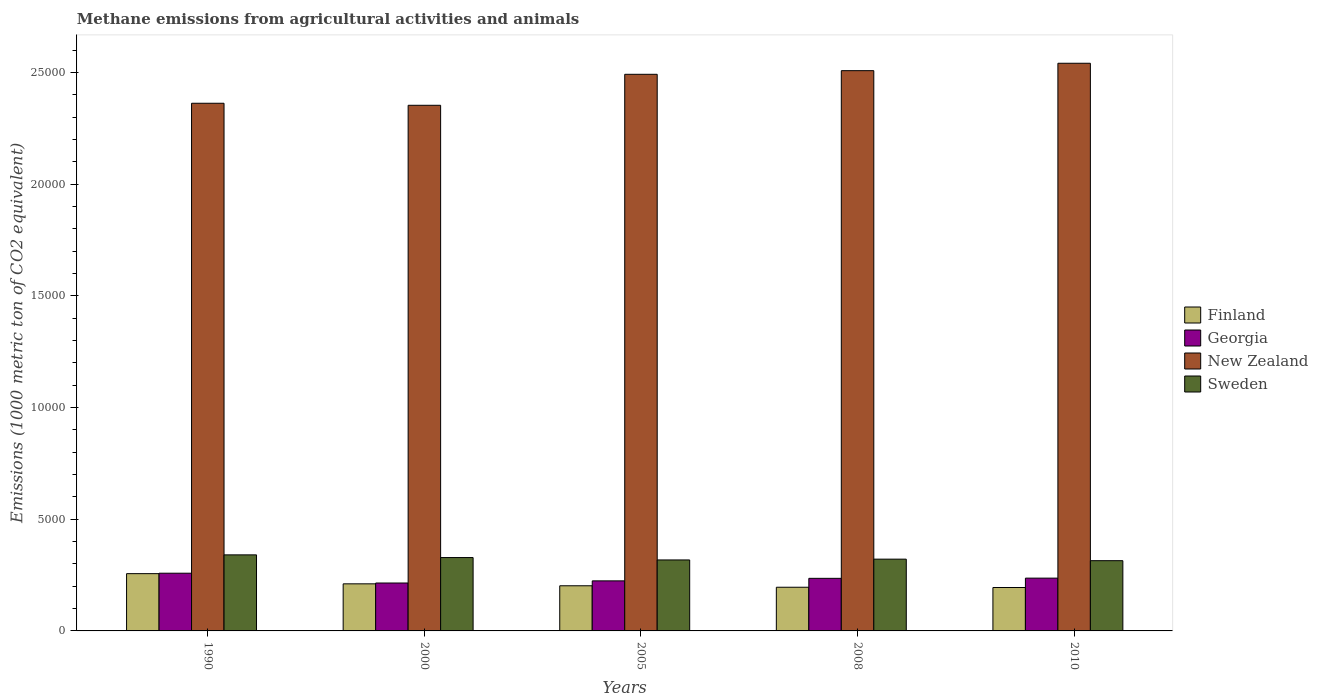How many groups of bars are there?
Offer a very short reply. 5. Are the number of bars per tick equal to the number of legend labels?
Provide a short and direct response. Yes. What is the label of the 1st group of bars from the left?
Provide a short and direct response. 1990. What is the amount of methane emitted in Finland in 2010?
Your answer should be very brief. 1943.6. Across all years, what is the maximum amount of methane emitted in Sweden?
Your response must be concise. 3404.5. Across all years, what is the minimum amount of methane emitted in New Zealand?
Keep it short and to the point. 2.35e+04. What is the total amount of methane emitted in Sweden in the graph?
Give a very brief answer. 1.62e+04. What is the difference between the amount of methane emitted in New Zealand in 2000 and that in 2008?
Keep it short and to the point. -1550.5. What is the difference between the amount of methane emitted in Sweden in 2008 and the amount of methane emitted in New Zealand in 2010?
Offer a terse response. -2.22e+04. What is the average amount of methane emitted in New Zealand per year?
Offer a terse response. 2.45e+04. In the year 2000, what is the difference between the amount of methane emitted in Georgia and amount of methane emitted in Finland?
Your answer should be compact. 37.1. What is the ratio of the amount of methane emitted in New Zealand in 2000 to that in 2008?
Your answer should be compact. 0.94. Is the amount of methane emitted in Georgia in 2005 less than that in 2008?
Offer a very short reply. Yes. What is the difference between the highest and the second highest amount of methane emitted in Georgia?
Ensure brevity in your answer.  220.6. What is the difference between the highest and the lowest amount of methane emitted in Sweden?
Make the answer very short. 259.9. Is it the case that in every year, the sum of the amount of methane emitted in New Zealand and amount of methane emitted in Finland is greater than the sum of amount of methane emitted in Sweden and amount of methane emitted in Georgia?
Your response must be concise. Yes. What does the 3rd bar from the left in 2008 represents?
Give a very brief answer. New Zealand. Is it the case that in every year, the sum of the amount of methane emitted in Sweden and amount of methane emitted in New Zealand is greater than the amount of methane emitted in Georgia?
Provide a short and direct response. Yes. How many years are there in the graph?
Your response must be concise. 5. What is the difference between two consecutive major ticks on the Y-axis?
Your answer should be very brief. 5000. Does the graph contain any zero values?
Make the answer very short. No. How many legend labels are there?
Provide a short and direct response. 4. What is the title of the graph?
Offer a very short reply. Methane emissions from agricultural activities and animals. What is the label or title of the Y-axis?
Give a very brief answer. Emissions (1000 metric ton of CO2 equivalent). What is the Emissions (1000 metric ton of CO2 equivalent) in Finland in 1990?
Offer a terse response. 2564. What is the Emissions (1000 metric ton of CO2 equivalent) in Georgia in 1990?
Provide a short and direct response. 2583.7. What is the Emissions (1000 metric ton of CO2 equivalent) of New Zealand in 1990?
Provide a succinct answer. 2.36e+04. What is the Emissions (1000 metric ton of CO2 equivalent) of Sweden in 1990?
Provide a succinct answer. 3404.5. What is the Emissions (1000 metric ton of CO2 equivalent) of Finland in 2000?
Your answer should be compact. 2107.9. What is the Emissions (1000 metric ton of CO2 equivalent) in Georgia in 2000?
Your answer should be compact. 2145. What is the Emissions (1000 metric ton of CO2 equivalent) of New Zealand in 2000?
Keep it short and to the point. 2.35e+04. What is the Emissions (1000 metric ton of CO2 equivalent) of Sweden in 2000?
Your response must be concise. 3284.7. What is the Emissions (1000 metric ton of CO2 equivalent) in Finland in 2005?
Your response must be concise. 2020.8. What is the Emissions (1000 metric ton of CO2 equivalent) of Georgia in 2005?
Your response must be concise. 2240.7. What is the Emissions (1000 metric ton of CO2 equivalent) of New Zealand in 2005?
Keep it short and to the point. 2.49e+04. What is the Emissions (1000 metric ton of CO2 equivalent) in Sweden in 2005?
Your answer should be compact. 3177.6. What is the Emissions (1000 metric ton of CO2 equivalent) in Finland in 2008?
Make the answer very short. 1955.7. What is the Emissions (1000 metric ton of CO2 equivalent) of Georgia in 2008?
Your answer should be compact. 2354. What is the Emissions (1000 metric ton of CO2 equivalent) of New Zealand in 2008?
Make the answer very short. 2.51e+04. What is the Emissions (1000 metric ton of CO2 equivalent) of Sweden in 2008?
Offer a terse response. 3213.3. What is the Emissions (1000 metric ton of CO2 equivalent) of Finland in 2010?
Provide a short and direct response. 1943.6. What is the Emissions (1000 metric ton of CO2 equivalent) in Georgia in 2010?
Provide a short and direct response. 2363.1. What is the Emissions (1000 metric ton of CO2 equivalent) in New Zealand in 2010?
Provide a short and direct response. 2.54e+04. What is the Emissions (1000 metric ton of CO2 equivalent) of Sweden in 2010?
Your answer should be very brief. 3144.6. Across all years, what is the maximum Emissions (1000 metric ton of CO2 equivalent) in Finland?
Your answer should be very brief. 2564. Across all years, what is the maximum Emissions (1000 metric ton of CO2 equivalent) of Georgia?
Offer a very short reply. 2583.7. Across all years, what is the maximum Emissions (1000 metric ton of CO2 equivalent) of New Zealand?
Keep it short and to the point. 2.54e+04. Across all years, what is the maximum Emissions (1000 metric ton of CO2 equivalent) of Sweden?
Offer a terse response. 3404.5. Across all years, what is the minimum Emissions (1000 metric ton of CO2 equivalent) of Finland?
Provide a short and direct response. 1943.6. Across all years, what is the minimum Emissions (1000 metric ton of CO2 equivalent) of Georgia?
Your answer should be very brief. 2145. Across all years, what is the minimum Emissions (1000 metric ton of CO2 equivalent) of New Zealand?
Keep it short and to the point. 2.35e+04. Across all years, what is the minimum Emissions (1000 metric ton of CO2 equivalent) in Sweden?
Offer a very short reply. 3144.6. What is the total Emissions (1000 metric ton of CO2 equivalent) of Finland in the graph?
Keep it short and to the point. 1.06e+04. What is the total Emissions (1000 metric ton of CO2 equivalent) of Georgia in the graph?
Offer a terse response. 1.17e+04. What is the total Emissions (1000 metric ton of CO2 equivalent) in New Zealand in the graph?
Your response must be concise. 1.23e+05. What is the total Emissions (1000 metric ton of CO2 equivalent) of Sweden in the graph?
Make the answer very short. 1.62e+04. What is the difference between the Emissions (1000 metric ton of CO2 equivalent) in Finland in 1990 and that in 2000?
Provide a succinct answer. 456.1. What is the difference between the Emissions (1000 metric ton of CO2 equivalent) of Georgia in 1990 and that in 2000?
Your answer should be very brief. 438.7. What is the difference between the Emissions (1000 metric ton of CO2 equivalent) of New Zealand in 1990 and that in 2000?
Make the answer very short. 90.9. What is the difference between the Emissions (1000 metric ton of CO2 equivalent) of Sweden in 1990 and that in 2000?
Offer a terse response. 119.8. What is the difference between the Emissions (1000 metric ton of CO2 equivalent) of Finland in 1990 and that in 2005?
Provide a short and direct response. 543.2. What is the difference between the Emissions (1000 metric ton of CO2 equivalent) in Georgia in 1990 and that in 2005?
Ensure brevity in your answer.  343. What is the difference between the Emissions (1000 metric ton of CO2 equivalent) in New Zealand in 1990 and that in 2005?
Make the answer very short. -1296. What is the difference between the Emissions (1000 metric ton of CO2 equivalent) in Sweden in 1990 and that in 2005?
Offer a terse response. 226.9. What is the difference between the Emissions (1000 metric ton of CO2 equivalent) in Finland in 1990 and that in 2008?
Your response must be concise. 608.3. What is the difference between the Emissions (1000 metric ton of CO2 equivalent) of Georgia in 1990 and that in 2008?
Your answer should be compact. 229.7. What is the difference between the Emissions (1000 metric ton of CO2 equivalent) of New Zealand in 1990 and that in 2008?
Ensure brevity in your answer.  -1459.6. What is the difference between the Emissions (1000 metric ton of CO2 equivalent) of Sweden in 1990 and that in 2008?
Offer a terse response. 191.2. What is the difference between the Emissions (1000 metric ton of CO2 equivalent) of Finland in 1990 and that in 2010?
Give a very brief answer. 620.4. What is the difference between the Emissions (1000 metric ton of CO2 equivalent) in Georgia in 1990 and that in 2010?
Make the answer very short. 220.6. What is the difference between the Emissions (1000 metric ton of CO2 equivalent) of New Zealand in 1990 and that in 2010?
Your response must be concise. -1790.8. What is the difference between the Emissions (1000 metric ton of CO2 equivalent) in Sweden in 1990 and that in 2010?
Give a very brief answer. 259.9. What is the difference between the Emissions (1000 metric ton of CO2 equivalent) of Finland in 2000 and that in 2005?
Your answer should be compact. 87.1. What is the difference between the Emissions (1000 metric ton of CO2 equivalent) in Georgia in 2000 and that in 2005?
Ensure brevity in your answer.  -95.7. What is the difference between the Emissions (1000 metric ton of CO2 equivalent) of New Zealand in 2000 and that in 2005?
Provide a succinct answer. -1386.9. What is the difference between the Emissions (1000 metric ton of CO2 equivalent) of Sweden in 2000 and that in 2005?
Provide a short and direct response. 107.1. What is the difference between the Emissions (1000 metric ton of CO2 equivalent) of Finland in 2000 and that in 2008?
Offer a terse response. 152.2. What is the difference between the Emissions (1000 metric ton of CO2 equivalent) of Georgia in 2000 and that in 2008?
Give a very brief answer. -209. What is the difference between the Emissions (1000 metric ton of CO2 equivalent) of New Zealand in 2000 and that in 2008?
Make the answer very short. -1550.5. What is the difference between the Emissions (1000 metric ton of CO2 equivalent) of Sweden in 2000 and that in 2008?
Your answer should be very brief. 71.4. What is the difference between the Emissions (1000 metric ton of CO2 equivalent) of Finland in 2000 and that in 2010?
Give a very brief answer. 164.3. What is the difference between the Emissions (1000 metric ton of CO2 equivalent) in Georgia in 2000 and that in 2010?
Give a very brief answer. -218.1. What is the difference between the Emissions (1000 metric ton of CO2 equivalent) of New Zealand in 2000 and that in 2010?
Your response must be concise. -1881.7. What is the difference between the Emissions (1000 metric ton of CO2 equivalent) of Sweden in 2000 and that in 2010?
Your response must be concise. 140.1. What is the difference between the Emissions (1000 metric ton of CO2 equivalent) in Finland in 2005 and that in 2008?
Give a very brief answer. 65.1. What is the difference between the Emissions (1000 metric ton of CO2 equivalent) in Georgia in 2005 and that in 2008?
Provide a succinct answer. -113.3. What is the difference between the Emissions (1000 metric ton of CO2 equivalent) of New Zealand in 2005 and that in 2008?
Provide a short and direct response. -163.6. What is the difference between the Emissions (1000 metric ton of CO2 equivalent) of Sweden in 2005 and that in 2008?
Ensure brevity in your answer.  -35.7. What is the difference between the Emissions (1000 metric ton of CO2 equivalent) in Finland in 2005 and that in 2010?
Offer a terse response. 77.2. What is the difference between the Emissions (1000 metric ton of CO2 equivalent) in Georgia in 2005 and that in 2010?
Make the answer very short. -122.4. What is the difference between the Emissions (1000 metric ton of CO2 equivalent) in New Zealand in 2005 and that in 2010?
Your answer should be compact. -494.8. What is the difference between the Emissions (1000 metric ton of CO2 equivalent) in Sweden in 2005 and that in 2010?
Ensure brevity in your answer.  33. What is the difference between the Emissions (1000 metric ton of CO2 equivalent) in New Zealand in 2008 and that in 2010?
Ensure brevity in your answer.  -331.2. What is the difference between the Emissions (1000 metric ton of CO2 equivalent) in Sweden in 2008 and that in 2010?
Provide a short and direct response. 68.7. What is the difference between the Emissions (1000 metric ton of CO2 equivalent) in Finland in 1990 and the Emissions (1000 metric ton of CO2 equivalent) in Georgia in 2000?
Your answer should be very brief. 419. What is the difference between the Emissions (1000 metric ton of CO2 equivalent) in Finland in 1990 and the Emissions (1000 metric ton of CO2 equivalent) in New Zealand in 2000?
Provide a short and direct response. -2.10e+04. What is the difference between the Emissions (1000 metric ton of CO2 equivalent) in Finland in 1990 and the Emissions (1000 metric ton of CO2 equivalent) in Sweden in 2000?
Offer a terse response. -720.7. What is the difference between the Emissions (1000 metric ton of CO2 equivalent) in Georgia in 1990 and the Emissions (1000 metric ton of CO2 equivalent) in New Zealand in 2000?
Provide a succinct answer. -2.09e+04. What is the difference between the Emissions (1000 metric ton of CO2 equivalent) in Georgia in 1990 and the Emissions (1000 metric ton of CO2 equivalent) in Sweden in 2000?
Offer a very short reply. -701. What is the difference between the Emissions (1000 metric ton of CO2 equivalent) in New Zealand in 1990 and the Emissions (1000 metric ton of CO2 equivalent) in Sweden in 2000?
Offer a terse response. 2.03e+04. What is the difference between the Emissions (1000 metric ton of CO2 equivalent) of Finland in 1990 and the Emissions (1000 metric ton of CO2 equivalent) of Georgia in 2005?
Keep it short and to the point. 323.3. What is the difference between the Emissions (1000 metric ton of CO2 equivalent) in Finland in 1990 and the Emissions (1000 metric ton of CO2 equivalent) in New Zealand in 2005?
Your answer should be very brief. -2.24e+04. What is the difference between the Emissions (1000 metric ton of CO2 equivalent) of Finland in 1990 and the Emissions (1000 metric ton of CO2 equivalent) of Sweden in 2005?
Make the answer very short. -613.6. What is the difference between the Emissions (1000 metric ton of CO2 equivalent) in Georgia in 1990 and the Emissions (1000 metric ton of CO2 equivalent) in New Zealand in 2005?
Keep it short and to the point. -2.23e+04. What is the difference between the Emissions (1000 metric ton of CO2 equivalent) in Georgia in 1990 and the Emissions (1000 metric ton of CO2 equivalent) in Sweden in 2005?
Offer a terse response. -593.9. What is the difference between the Emissions (1000 metric ton of CO2 equivalent) in New Zealand in 1990 and the Emissions (1000 metric ton of CO2 equivalent) in Sweden in 2005?
Your answer should be compact. 2.04e+04. What is the difference between the Emissions (1000 metric ton of CO2 equivalent) in Finland in 1990 and the Emissions (1000 metric ton of CO2 equivalent) in Georgia in 2008?
Make the answer very short. 210. What is the difference between the Emissions (1000 metric ton of CO2 equivalent) in Finland in 1990 and the Emissions (1000 metric ton of CO2 equivalent) in New Zealand in 2008?
Your response must be concise. -2.25e+04. What is the difference between the Emissions (1000 metric ton of CO2 equivalent) of Finland in 1990 and the Emissions (1000 metric ton of CO2 equivalent) of Sweden in 2008?
Offer a terse response. -649.3. What is the difference between the Emissions (1000 metric ton of CO2 equivalent) of Georgia in 1990 and the Emissions (1000 metric ton of CO2 equivalent) of New Zealand in 2008?
Offer a very short reply. -2.25e+04. What is the difference between the Emissions (1000 metric ton of CO2 equivalent) in Georgia in 1990 and the Emissions (1000 metric ton of CO2 equivalent) in Sweden in 2008?
Give a very brief answer. -629.6. What is the difference between the Emissions (1000 metric ton of CO2 equivalent) in New Zealand in 1990 and the Emissions (1000 metric ton of CO2 equivalent) in Sweden in 2008?
Offer a very short reply. 2.04e+04. What is the difference between the Emissions (1000 metric ton of CO2 equivalent) of Finland in 1990 and the Emissions (1000 metric ton of CO2 equivalent) of Georgia in 2010?
Give a very brief answer. 200.9. What is the difference between the Emissions (1000 metric ton of CO2 equivalent) in Finland in 1990 and the Emissions (1000 metric ton of CO2 equivalent) in New Zealand in 2010?
Your answer should be compact. -2.28e+04. What is the difference between the Emissions (1000 metric ton of CO2 equivalent) of Finland in 1990 and the Emissions (1000 metric ton of CO2 equivalent) of Sweden in 2010?
Offer a very short reply. -580.6. What is the difference between the Emissions (1000 metric ton of CO2 equivalent) in Georgia in 1990 and the Emissions (1000 metric ton of CO2 equivalent) in New Zealand in 2010?
Make the answer very short. -2.28e+04. What is the difference between the Emissions (1000 metric ton of CO2 equivalent) of Georgia in 1990 and the Emissions (1000 metric ton of CO2 equivalent) of Sweden in 2010?
Offer a very short reply. -560.9. What is the difference between the Emissions (1000 metric ton of CO2 equivalent) in New Zealand in 1990 and the Emissions (1000 metric ton of CO2 equivalent) in Sweden in 2010?
Make the answer very short. 2.05e+04. What is the difference between the Emissions (1000 metric ton of CO2 equivalent) in Finland in 2000 and the Emissions (1000 metric ton of CO2 equivalent) in Georgia in 2005?
Keep it short and to the point. -132.8. What is the difference between the Emissions (1000 metric ton of CO2 equivalent) in Finland in 2000 and the Emissions (1000 metric ton of CO2 equivalent) in New Zealand in 2005?
Ensure brevity in your answer.  -2.28e+04. What is the difference between the Emissions (1000 metric ton of CO2 equivalent) in Finland in 2000 and the Emissions (1000 metric ton of CO2 equivalent) in Sweden in 2005?
Your answer should be very brief. -1069.7. What is the difference between the Emissions (1000 metric ton of CO2 equivalent) in Georgia in 2000 and the Emissions (1000 metric ton of CO2 equivalent) in New Zealand in 2005?
Provide a succinct answer. -2.28e+04. What is the difference between the Emissions (1000 metric ton of CO2 equivalent) in Georgia in 2000 and the Emissions (1000 metric ton of CO2 equivalent) in Sweden in 2005?
Ensure brevity in your answer.  -1032.6. What is the difference between the Emissions (1000 metric ton of CO2 equivalent) of New Zealand in 2000 and the Emissions (1000 metric ton of CO2 equivalent) of Sweden in 2005?
Make the answer very short. 2.04e+04. What is the difference between the Emissions (1000 metric ton of CO2 equivalent) of Finland in 2000 and the Emissions (1000 metric ton of CO2 equivalent) of Georgia in 2008?
Ensure brevity in your answer.  -246.1. What is the difference between the Emissions (1000 metric ton of CO2 equivalent) in Finland in 2000 and the Emissions (1000 metric ton of CO2 equivalent) in New Zealand in 2008?
Ensure brevity in your answer.  -2.30e+04. What is the difference between the Emissions (1000 metric ton of CO2 equivalent) in Finland in 2000 and the Emissions (1000 metric ton of CO2 equivalent) in Sweden in 2008?
Offer a very short reply. -1105.4. What is the difference between the Emissions (1000 metric ton of CO2 equivalent) in Georgia in 2000 and the Emissions (1000 metric ton of CO2 equivalent) in New Zealand in 2008?
Provide a succinct answer. -2.29e+04. What is the difference between the Emissions (1000 metric ton of CO2 equivalent) in Georgia in 2000 and the Emissions (1000 metric ton of CO2 equivalent) in Sweden in 2008?
Offer a very short reply. -1068.3. What is the difference between the Emissions (1000 metric ton of CO2 equivalent) in New Zealand in 2000 and the Emissions (1000 metric ton of CO2 equivalent) in Sweden in 2008?
Provide a succinct answer. 2.03e+04. What is the difference between the Emissions (1000 metric ton of CO2 equivalent) of Finland in 2000 and the Emissions (1000 metric ton of CO2 equivalent) of Georgia in 2010?
Offer a terse response. -255.2. What is the difference between the Emissions (1000 metric ton of CO2 equivalent) of Finland in 2000 and the Emissions (1000 metric ton of CO2 equivalent) of New Zealand in 2010?
Your response must be concise. -2.33e+04. What is the difference between the Emissions (1000 metric ton of CO2 equivalent) in Finland in 2000 and the Emissions (1000 metric ton of CO2 equivalent) in Sweden in 2010?
Your response must be concise. -1036.7. What is the difference between the Emissions (1000 metric ton of CO2 equivalent) of Georgia in 2000 and the Emissions (1000 metric ton of CO2 equivalent) of New Zealand in 2010?
Offer a very short reply. -2.33e+04. What is the difference between the Emissions (1000 metric ton of CO2 equivalent) in Georgia in 2000 and the Emissions (1000 metric ton of CO2 equivalent) in Sweden in 2010?
Your answer should be very brief. -999.6. What is the difference between the Emissions (1000 metric ton of CO2 equivalent) of New Zealand in 2000 and the Emissions (1000 metric ton of CO2 equivalent) of Sweden in 2010?
Make the answer very short. 2.04e+04. What is the difference between the Emissions (1000 metric ton of CO2 equivalent) of Finland in 2005 and the Emissions (1000 metric ton of CO2 equivalent) of Georgia in 2008?
Provide a short and direct response. -333.2. What is the difference between the Emissions (1000 metric ton of CO2 equivalent) of Finland in 2005 and the Emissions (1000 metric ton of CO2 equivalent) of New Zealand in 2008?
Ensure brevity in your answer.  -2.31e+04. What is the difference between the Emissions (1000 metric ton of CO2 equivalent) of Finland in 2005 and the Emissions (1000 metric ton of CO2 equivalent) of Sweden in 2008?
Offer a very short reply. -1192.5. What is the difference between the Emissions (1000 metric ton of CO2 equivalent) of Georgia in 2005 and the Emissions (1000 metric ton of CO2 equivalent) of New Zealand in 2008?
Ensure brevity in your answer.  -2.28e+04. What is the difference between the Emissions (1000 metric ton of CO2 equivalent) in Georgia in 2005 and the Emissions (1000 metric ton of CO2 equivalent) in Sweden in 2008?
Offer a very short reply. -972.6. What is the difference between the Emissions (1000 metric ton of CO2 equivalent) in New Zealand in 2005 and the Emissions (1000 metric ton of CO2 equivalent) in Sweden in 2008?
Offer a very short reply. 2.17e+04. What is the difference between the Emissions (1000 metric ton of CO2 equivalent) in Finland in 2005 and the Emissions (1000 metric ton of CO2 equivalent) in Georgia in 2010?
Your answer should be very brief. -342.3. What is the difference between the Emissions (1000 metric ton of CO2 equivalent) in Finland in 2005 and the Emissions (1000 metric ton of CO2 equivalent) in New Zealand in 2010?
Ensure brevity in your answer.  -2.34e+04. What is the difference between the Emissions (1000 metric ton of CO2 equivalent) in Finland in 2005 and the Emissions (1000 metric ton of CO2 equivalent) in Sweden in 2010?
Your response must be concise. -1123.8. What is the difference between the Emissions (1000 metric ton of CO2 equivalent) in Georgia in 2005 and the Emissions (1000 metric ton of CO2 equivalent) in New Zealand in 2010?
Provide a succinct answer. -2.32e+04. What is the difference between the Emissions (1000 metric ton of CO2 equivalent) in Georgia in 2005 and the Emissions (1000 metric ton of CO2 equivalent) in Sweden in 2010?
Provide a succinct answer. -903.9. What is the difference between the Emissions (1000 metric ton of CO2 equivalent) of New Zealand in 2005 and the Emissions (1000 metric ton of CO2 equivalent) of Sweden in 2010?
Your answer should be compact. 2.18e+04. What is the difference between the Emissions (1000 metric ton of CO2 equivalent) in Finland in 2008 and the Emissions (1000 metric ton of CO2 equivalent) in Georgia in 2010?
Offer a terse response. -407.4. What is the difference between the Emissions (1000 metric ton of CO2 equivalent) of Finland in 2008 and the Emissions (1000 metric ton of CO2 equivalent) of New Zealand in 2010?
Provide a succinct answer. -2.35e+04. What is the difference between the Emissions (1000 metric ton of CO2 equivalent) in Finland in 2008 and the Emissions (1000 metric ton of CO2 equivalent) in Sweden in 2010?
Provide a succinct answer. -1188.9. What is the difference between the Emissions (1000 metric ton of CO2 equivalent) in Georgia in 2008 and the Emissions (1000 metric ton of CO2 equivalent) in New Zealand in 2010?
Give a very brief answer. -2.31e+04. What is the difference between the Emissions (1000 metric ton of CO2 equivalent) of Georgia in 2008 and the Emissions (1000 metric ton of CO2 equivalent) of Sweden in 2010?
Keep it short and to the point. -790.6. What is the difference between the Emissions (1000 metric ton of CO2 equivalent) of New Zealand in 2008 and the Emissions (1000 metric ton of CO2 equivalent) of Sweden in 2010?
Provide a short and direct response. 2.19e+04. What is the average Emissions (1000 metric ton of CO2 equivalent) of Finland per year?
Offer a very short reply. 2118.4. What is the average Emissions (1000 metric ton of CO2 equivalent) of Georgia per year?
Offer a very short reply. 2337.3. What is the average Emissions (1000 metric ton of CO2 equivalent) of New Zealand per year?
Your response must be concise. 2.45e+04. What is the average Emissions (1000 metric ton of CO2 equivalent) in Sweden per year?
Your answer should be very brief. 3244.94. In the year 1990, what is the difference between the Emissions (1000 metric ton of CO2 equivalent) in Finland and Emissions (1000 metric ton of CO2 equivalent) in Georgia?
Your answer should be very brief. -19.7. In the year 1990, what is the difference between the Emissions (1000 metric ton of CO2 equivalent) of Finland and Emissions (1000 metric ton of CO2 equivalent) of New Zealand?
Your answer should be very brief. -2.11e+04. In the year 1990, what is the difference between the Emissions (1000 metric ton of CO2 equivalent) of Finland and Emissions (1000 metric ton of CO2 equivalent) of Sweden?
Ensure brevity in your answer.  -840.5. In the year 1990, what is the difference between the Emissions (1000 metric ton of CO2 equivalent) of Georgia and Emissions (1000 metric ton of CO2 equivalent) of New Zealand?
Provide a succinct answer. -2.10e+04. In the year 1990, what is the difference between the Emissions (1000 metric ton of CO2 equivalent) of Georgia and Emissions (1000 metric ton of CO2 equivalent) of Sweden?
Keep it short and to the point. -820.8. In the year 1990, what is the difference between the Emissions (1000 metric ton of CO2 equivalent) of New Zealand and Emissions (1000 metric ton of CO2 equivalent) of Sweden?
Make the answer very short. 2.02e+04. In the year 2000, what is the difference between the Emissions (1000 metric ton of CO2 equivalent) in Finland and Emissions (1000 metric ton of CO2 equivalent) in Georgia?
Give a very brief answer. -37.1. In the year 2000, what is the difference between the Emissions (1000 metric ton of CO2 equivalent) of Finland and Emissions (1000 metric ton of CO2 equivalent) of New Zealand?
Ensure brevity in your answer.  -2.14e+04. In the year 2000, what is the difference between the Emissions (1000 metric ton of CO2 equivalent) in Finland and Emissions (1000 metric ton of CO2 equivalent) in Sweden?
Keep it short and to the point. -1176.8. In the year 2000, what is the difference between the Emissions (1000 metric ton of CO2 equivalent) of Georgia and Emissions (1000 metric ton of CO2 equivalent) of New Zealand?
Provide a short and direct response. -2.14e+04. In the year 2000, what is the difference between the Emissions (1000 metric ton of CO2 equivalent) in Georgia and Emissions (1000 metric ton of CO2 equivalent) in Sweden?
Your response must be concise. -1139.7. In the year 2000, what is the difference between the Emissions (1000 metric ton of CO2 equivalent) in New Zealand and Emissions (1000 metric ton of CO2 equivalent) in Sweden?
Provide a short and direct response. 2.02e+04. In the year 2005, what is the difference between the Emissions (1000 metric ton of CO2 equivalent) of Finland and Emissions (1000 metric ton of CO2 equivalent) of Georgia?
Ensure brevity in your answer.  -219.9. In the year 2005, what is the difference between the Emissions (1000 metric ton of CO2 equivalent) in Finland and Emissions (1000 metric ton of CO2 equivalent) in New Zealand?
Your answer should be very brief. -2.29e+04. In the year 2005, what is the difference between the Emissions (1000 metric ton of CO2 equivalent) in Finland and Emissions (1000 metric ton of CO2 equivalent) in Sweden?
Offer a very short reply. -1156.8. In the year 2005, what is the difference between the Emissions (1000 metric ton of CO2 equivalent) in Georgia and Emissions (1000 metric ton of CO2 equivalent) in New Zealand?
Provide a succinct answer. -2.27e+04. In the year 2005, what is the difference between the Emissions (1000 metric ton of CO2 equivalent) in Georgia and Emissions (1000 metric ton of CO2 equivalent) in Sweden?
Provide a succinct answer. -936.9. In the year 2005, what is the difference between the Emissions (1000 metric ton of CO2 equivalent) of New Zealand and Emissions (1000 metric ton of CO2 equivalent) of Sweden?
Make the answer very short. 2.17e+04. In the year 2008, what is the difference between the Emissions (1000 metric ton of CO2 equivalent) in Finland and Emissions (1000 metric ton of CO2 equivalent) in Georgia?
Offer a very short reply. -398.3. In the year 2008, what is the difference between the Emissions (1000 metric ton of CO2 equivalent) of Finland and Emissions (1000 metric ton of CO2 equivalent) of New Zealand?
Provide a succinct answer. -2.31e+04. In the year 2008, what is the difference between the Emissions (1000 metric ton of CO2 equivalent) in Finland and Emissions (1000 metric ton of CO2 equivalent) in Sweden?
Keep it short and to the point. -1257.6. In the year 2008, what is the difference between the Emissions (1000 metric ton of CO2 equivalent) in Georgia and Emissions (1000 metric ton of CO2 equivalent) in New Zealand?
Your answer should be very brief. -2.27e+04. In the year 2008, what is the difference between the Emissions (1000 metric ton of CO2 equivalent) of Georgia and Emissions (1000 metric ton of CO2 equivalent) of Sweden?
Your answer should be compact. -859.3. In the year 2008, what is the difference between the Emissions (1000 metric ton of CO2 equivalent) of New Zealand and Emissions (1000 metric ton of CO2 equivalent) of Sweden?
Provide a succinct answer. 2.19e+04. In the year 2010, what is the difference between the Emissions (1000 metric ton of CO2 equivalent) of Finland and Emissions (1000 metric ton of CO2 equivalent) of Georgia?
Keep it short and to the point. -419.5. In the year 2010, what is the difference between the Emissions (1000 metric ton of CO2 equivalent) in Finland and Emissions (1000 metric ton of CO2 equivalent) in New Zealand?
Give a very brief answer. -2.35e+04. In the year 2010, what is the difference between the Emissions (1000 metric ton of CO2 equivalent) in Finland and Emissions (1000 metric ton of CO2 equivalent) in Sweden?
Your response must be concise. -1201. In the year 2010, what is the difference between the Emissions (1000 metric ton of CO2 equivalent) in Georgia and Emissions (1000 metric ton of CO2 equivalent) in New Zealand?
Give a very brief answer. -2.30e+04. In the year 2010, what is the difference between the Emissions (1000 metric ton of CO2 equivalent) of Georgia and Emissions (1000 metric ton of CO2 equivalent) of Sweden?
Offer a terse response. -781.5. In the year 2010, what is the difference between the Emissions (1000 metric ton of CO2 equivalent) in New Zealand and Emissions (1000 metric ton of CO2 equivalent) in Sweden?
Your answer should be compact. 2.23e+04. What is the ratio of the Emissions (1000 metric ton of CO2 equivalent) of Finland in 1990 to that in 2000?
Offer a very short reply. 1.22. What is the ratio of the Emissions (1000 metric ton of CO2 equivalent) of Georgia in 1990 to that in 2000?
Your answer should be very brief. 1.2. What is the ratio of the Emissions (1000 metric ton of CO2 equivalent) of Sweden in 1990 to that in 2000?
Make the answer very short. 1.04. What is the ratio of the Emissions (1000 metric ton of CO2 equivalent) of Finland in 1990 to that in 2005?
Offer a very short reply. 1.27. What is the ratio of the Emissions (1000 metric ton of CO2 equivalent) of Georgia in 1990 to that in 2005?
Your answer should be very brief. 1.15. What is the ratio of the Emissions (1000 metric ton of CO2 equivalent) of New Zealand in 1990 to that in 2005?
Offer a terse response. 0.95. What is the ratio of the Emissions (1000 metric ton of CO2 equivalent) in Sweden in 1990 to that in 2005?
Provide a succinct answer. 1.07. What is the ratio of the Emissions (1000 metric ton of CO2 equivalent) in Finland in 1990 to that in 2008?
Offer a very short reply. 1.31. What is the ratio of the Emissions (1000 metric ton of CO2 equivalent) in Georgia in 1990 to that in 2008?
Ensure brevity in your answer.  1.1. What is the ratio of the Emissions (1000 metric ton of CO2 equivalent) in New Zealand in 1990 to that in 2008?
Give a very brief answer. 0.94. What is the ratio of the Emissions (1000 metric ton of CO2 equivalent) in Sweden in 1990 to that in 2008?
Provide a succinct answer. 1.06. What is the ratio of the Emissions (1000 metric ton of CO2 equivalent) in Finland in 1990 to that in 2010?
Offer a very short reply. 1.32. What is the ratio of the Emissions (1000 metric ton of CO2 equivalent) of Georgia in 1990 to that in 2010?
Offer a very short reply. 1.09. What is the ratio of the Emissions (1000 metric ton of CO2 equivalent) in New Zealand in 1990 to that in 2010?
Your answer should be very brief. 0.93. What is the ratio of the Emissions (1000 metric ton of CO2 equivalent) of Sweden in 1990 to that in 2010?
Offer a terse response. 1.08. What is the ratio of the Emissions (1000 metric ton of CO2 equivalent) of Finland in 2000 to that in 2005?
Provide a short and direct response. 1.04. What is the ratio of the Emissions (1000 metric ton of CO2 equivalent) of Georgia in 2000 to that in 2005?
Ensure brevity in your answer.  0.96. What is the ratio of the Emissions (1000 metric ton of CO2 equivalent) in New Zealand in 2000 to that in 2005?
Offer a very short reply. 0.94. What is the ratio of the Emissions (1000 metric ton of CO2 equivalent) in Sweden in 2000 to that in 2005?
Ensure brevity in your answer.  1.03. What is the ratio of the Emissions (1000 metric ton of CO2 equivalent) of Finland in 2000 to that in 2008?
Make the answer very short. 1.08. What is the ratio of the Emissions (1000 metric ton of CO2 equivalent) of Georgia in 2000 to that in 2008?
Offer a terse response. 0.91. What is the ratio of the Emissions (1000 metric ton of CO2 equivalent) in New Zealand in 2000 to that in 2008?
Offer a terse response. 0.94. What is the ratio of the Emissions (1000 metric ton of CO2 equivalent) of Sweden in 2000 to that in 2008?
Your answer should be compact. 1.02. What is the ratio of the Emissions (1000 metric ton of CO2 equivalent) of Finland in 2000 to that in 2010?
Your answer should be compact. 1.08. What is the ratio of the Emissions (1000 metric ton of CO2 equivalent) of Georgia in 2000 to that in 2010?
Your answer should be compact. 0.91. What is the ratio of the Emissions (1000 metric ton of CO2 equivalent) in New Zealand in 2000 to that in 2010?
Ensure brevity in your answer.  0.93. What is the ratio of the Emissions (1000 metric ton of CO2 equivalent) in Sweden in 2000 to that in 2010?
Your response must be concise. 1.04. What is the ratio of the Emissions (1000 metric ton of CO2 equivalent) of Finland in 2005 to that in 2008?
Ensure brevity in your answer.  1.03. What is the ratio of the Emissions (1000 metric ton of CO2 equivalent) of Georgia in 2005 to that in 2008?
Offer a terse response. 0.95. What is the ratio of the Emissions (1000 metric ton of CO2 equivalent) of Sweden in 2005 to that in 2008?
Offer a very short reply. 0.99. What is the ratio of the Emissions (1000 metric ton of CO2 equivalent) of Finland in 2005 to that in 2010?
Your answer should be very brief. 1.04. What is the ratio of the Emissions (1000 metric ton of CO2 equivalent) of Georgia in 2005 to that in 2010?
Your response must be concise. 0.95. What is the ratio of the Emissions (1000 metric ton of CO2 equivalent) of New Zealand in 2005 to that in 2010?
Give a very brief answer. 0.98. What is the ratio of the Emissions (1000 metric ton of CO2 equivalent) in Sweden in 2005 to that in 2010?
Offer a very short reply. 1.01. What is the ratio of the Emissions (1000 metric ton of CO2 equivalent) in New Zealand in 2008 to that in 2010?
Give a very brief answer. 0.99. What is the ratio of the Emissions (1000 metric ton of CO2 equivalent) of Sweden in 2008 to that in 2010?
Offer a very short reply. 1.02. What is the difference between the highest and the second highest Emissions (1000 metric ton of CO2 equivalent) in Finland?
Your response must be concise. 456.1. What is the difference between the highest and the second highest Emissions (1000 metric ton of CO2 equivalent) in Georgia?
Keep it short and to the point. 220.6. What is the difference between the highest and the second highest Emissions (1000 metric ton of CO2 equivalent) of New Zealand?
Ensure brevity in your answer.  331.2. What is the difference between the highest and the second highest Emissions (1000 metric ton of CO2 equivalent) of Sweden?
Offer a very short reply. 119.8. What is the difference between the highest and the lowest Emissions (1000 metric ton of CO2 equivalent) of Finland?
Give a very brief answer. 620.4. What is the difference between the highest and the lowest Emissions (1000 metric ton of CO2 equivalent) of Georgia?
Give a very brief answer. 438.7. What is the difference between the highest and the lowest Emissions (1000 metric ton of CO2 equivalent) in New Zealand?
Ensure brevity in your answer.  1881.7. What is the difference between the highest and the lowest Emissions (1000 metric ton of CO2 equivalent) in Sweden?
Make the answer very short. 259.9. 